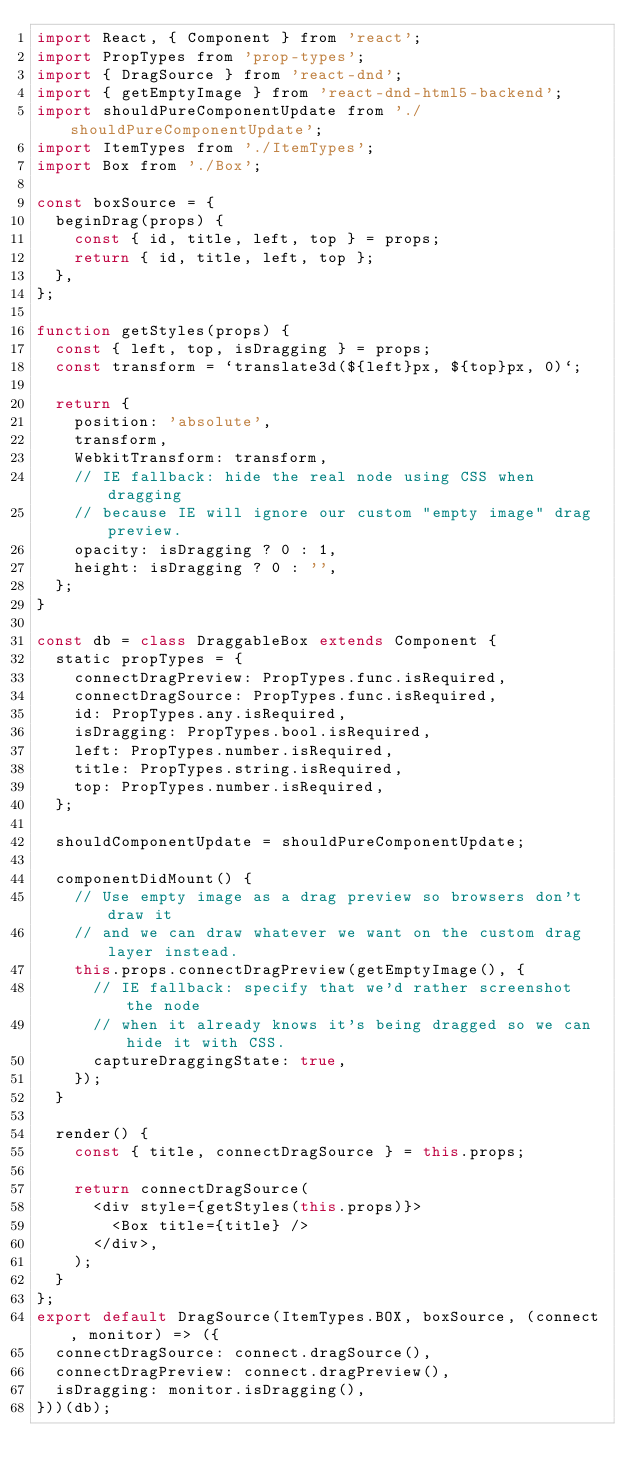Convert code to text. <code><loc_0><loc_0><loc_500><loc_500><_JavaScript_>import React, { Component } from 'react';
import PropTypes from 'prop-types';
import { DragSource } from 'react-dnd';
import { getEmptyImage } from 'react-dnd-html5-backend';
import shouldPureComponentUpdate from './shouldPureComponentUpdate';
import ItemTypes from './ItemTypes';
import Box from './Box';

const boxSource = {
  beginDrag(props) {
    const { id, title, left, top } = props;
    return { id, title, left, top };
  },
};

function getStyles(props) {
  const { left, top, isDragging } = props;
  const transform = `translate3d(${left}px, ${top}px, 0)`;

  return {
    position: 'absolute',
    transform,
    WebkitTransform: transform,
    // IE fallback: hide the real node using CSS when dragging
    // because IE will ignore our custom "empty image" drag preview.
    opacity: isDragging ? 0 : 1,
    height: isDragging ? 0 : '',
  };
}

const db = class DraggableBox extends Component {
  static propTypes = {
    connectDragPreview: PropTypes.func.isRequired,
    connectDragSource: PropTypes.func.isRequired,
    id: PropTypes.any.isRequired,
    isDragging: PropTypes.bool.isRequired,
    left: PropTypes.number.isRequired,
    title: PropTypes.string.isRequired,
    top: PropTypes.number.isRequired,
  };

  shouldComponentUpdate = shouldPureComponentUpdate;

  componentDidMount() {
    // Use empty image as a drag preview so browsers don't draw it
    // and we can draw whatever we want on the custom drag layer instead.
    this.props.connectDragPreview(getEmptyImage(), {
      // IE fallback: specify that we'd rather screenshot the node
      // when it already knows it's being dragged so we can hide it with CSS.
      captureDraggingState: true,
    });
  }

  render() {
    const { title, connectDragSource } = this.props;

    return connectDragSource(
      <div style={getStyles(this.props)}>
        <Box title={title} />
      </div>,
    );
  }
};
export default DragSource(ItemTypes.BOX, boxSource, (connect, monitor) => ({
  connectDragSource: connect.dragSource(),
  connectDragPreview: connect.dragPreview(),
  isDragging: monitor.isDragging(),
}))(db);
</code> 